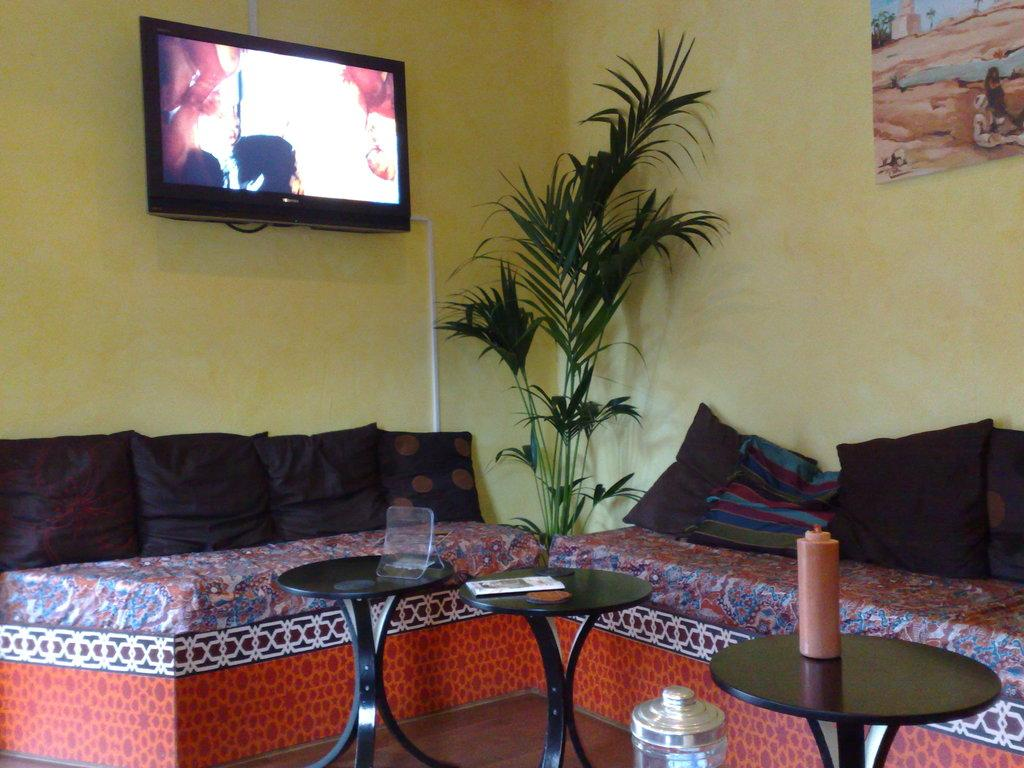What is the main object in the image? There is a television in the image. What color is the wall behind the television? The television is attached to a yellow wall. What type of furniture is in front of the television? There are sofas and tables in front of the television. What type of pies can be seen on the tables in the image? There are no pies present in the image; it only features a television, a yellow wall, sofas, and tables. 